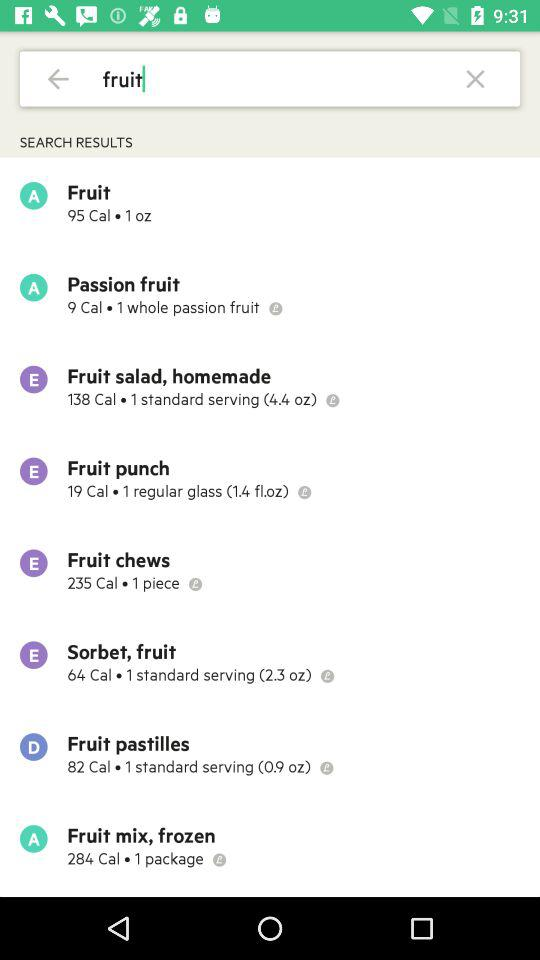Which fruit has 284 calories? The fruit is "Fruit mix, frozen". 